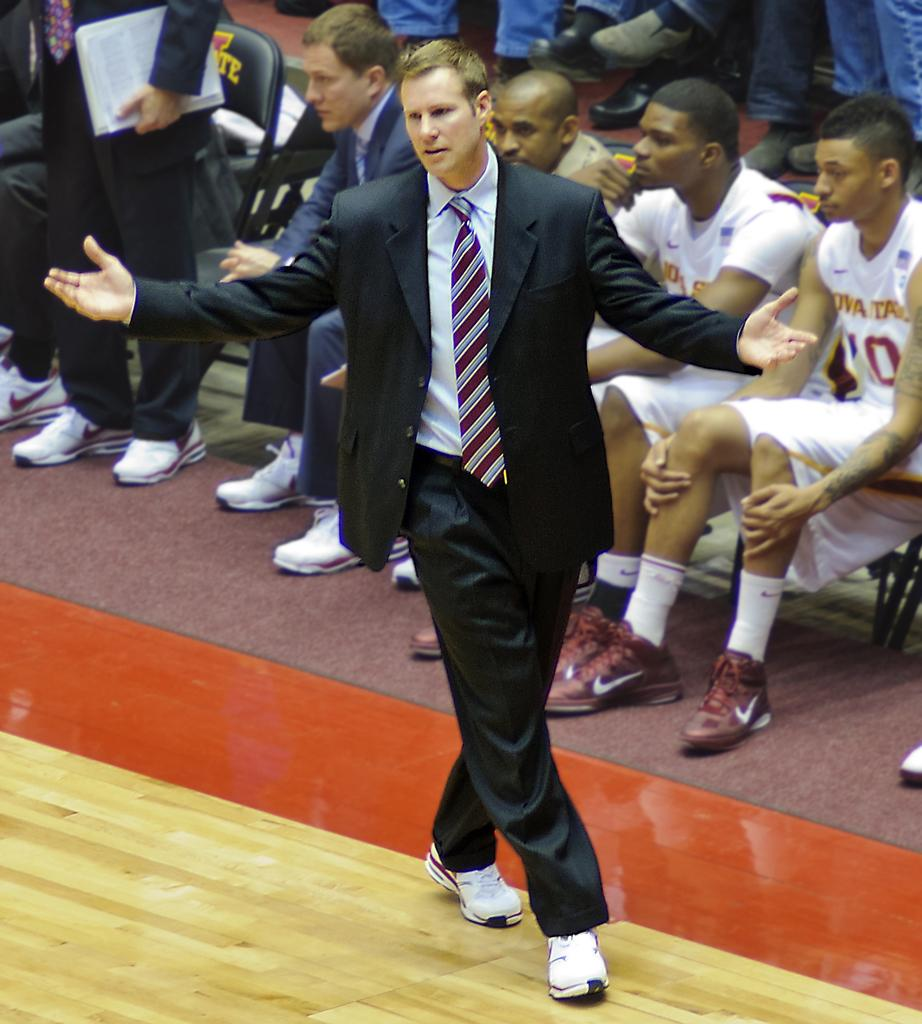What are the people in the image doing? There are people sitting in chairs and a man walking in the image. Can you describe the standing person in the image? The standing person is holding papers in their hand. What type of orange is being used as a peace offering in the image? There is no orange or peace offering present in the image. How many pizzas are being served to the people in the image? There is no mention of pizzas in the image. 